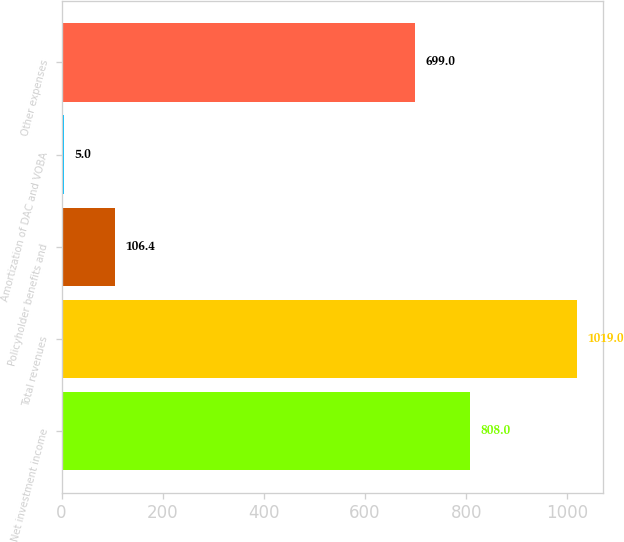Convert chart to OTSL. <chart><loc_0><loc_0><loc_500><loc_500><bar_chart><fcel>Net investment income<fcel>Total revenues<fcel>Policyholder benefits and<fcel>Amortization of DAC and VOBA<fcel>Other expenses<nl><fcel>808<fcel>1019<fcel>106.4<fcel>5<fcel>699<nl></chart> 